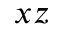Convert formula to latex. <formula><loc_0><loc_0><loc_500><loc_500>x z</formula> 